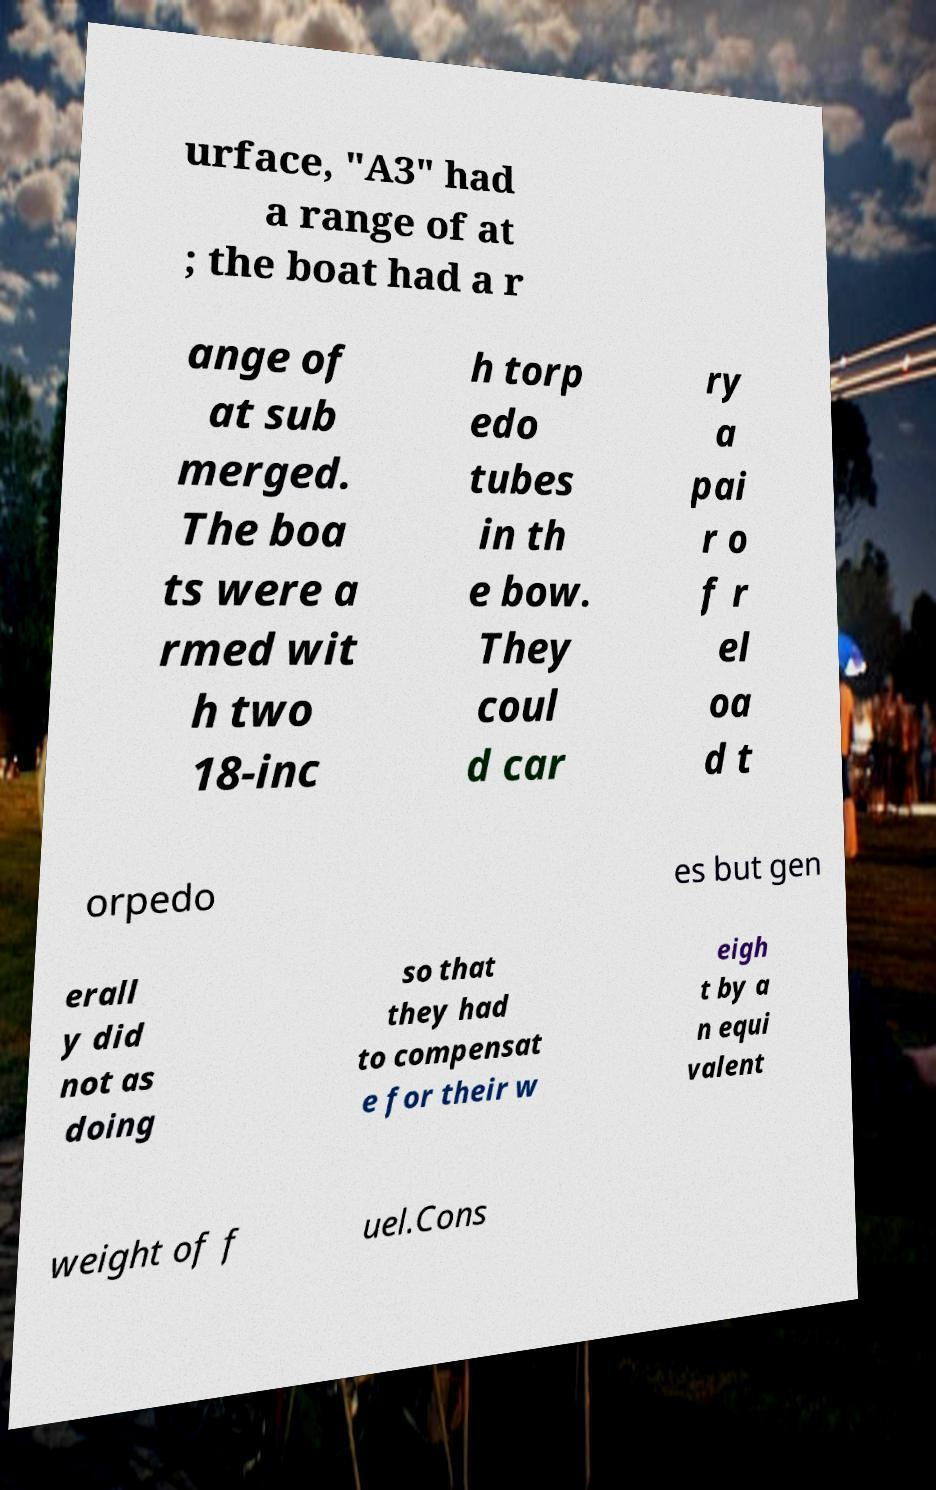Can you accurately transcribe the text from the provided image for me? urface, "A3" had a range of at ; the boat had a r ange of at sub merged. The boa ts were a rmed wit h two 18-inc h torp edo tubes in th e bow. They coul d car ry a pai r o f r el oa d t orpedo es but gen erall y did not as doing so that they had to compensat e for their w eigh t by a n equi valent weight of f uel.Cons 